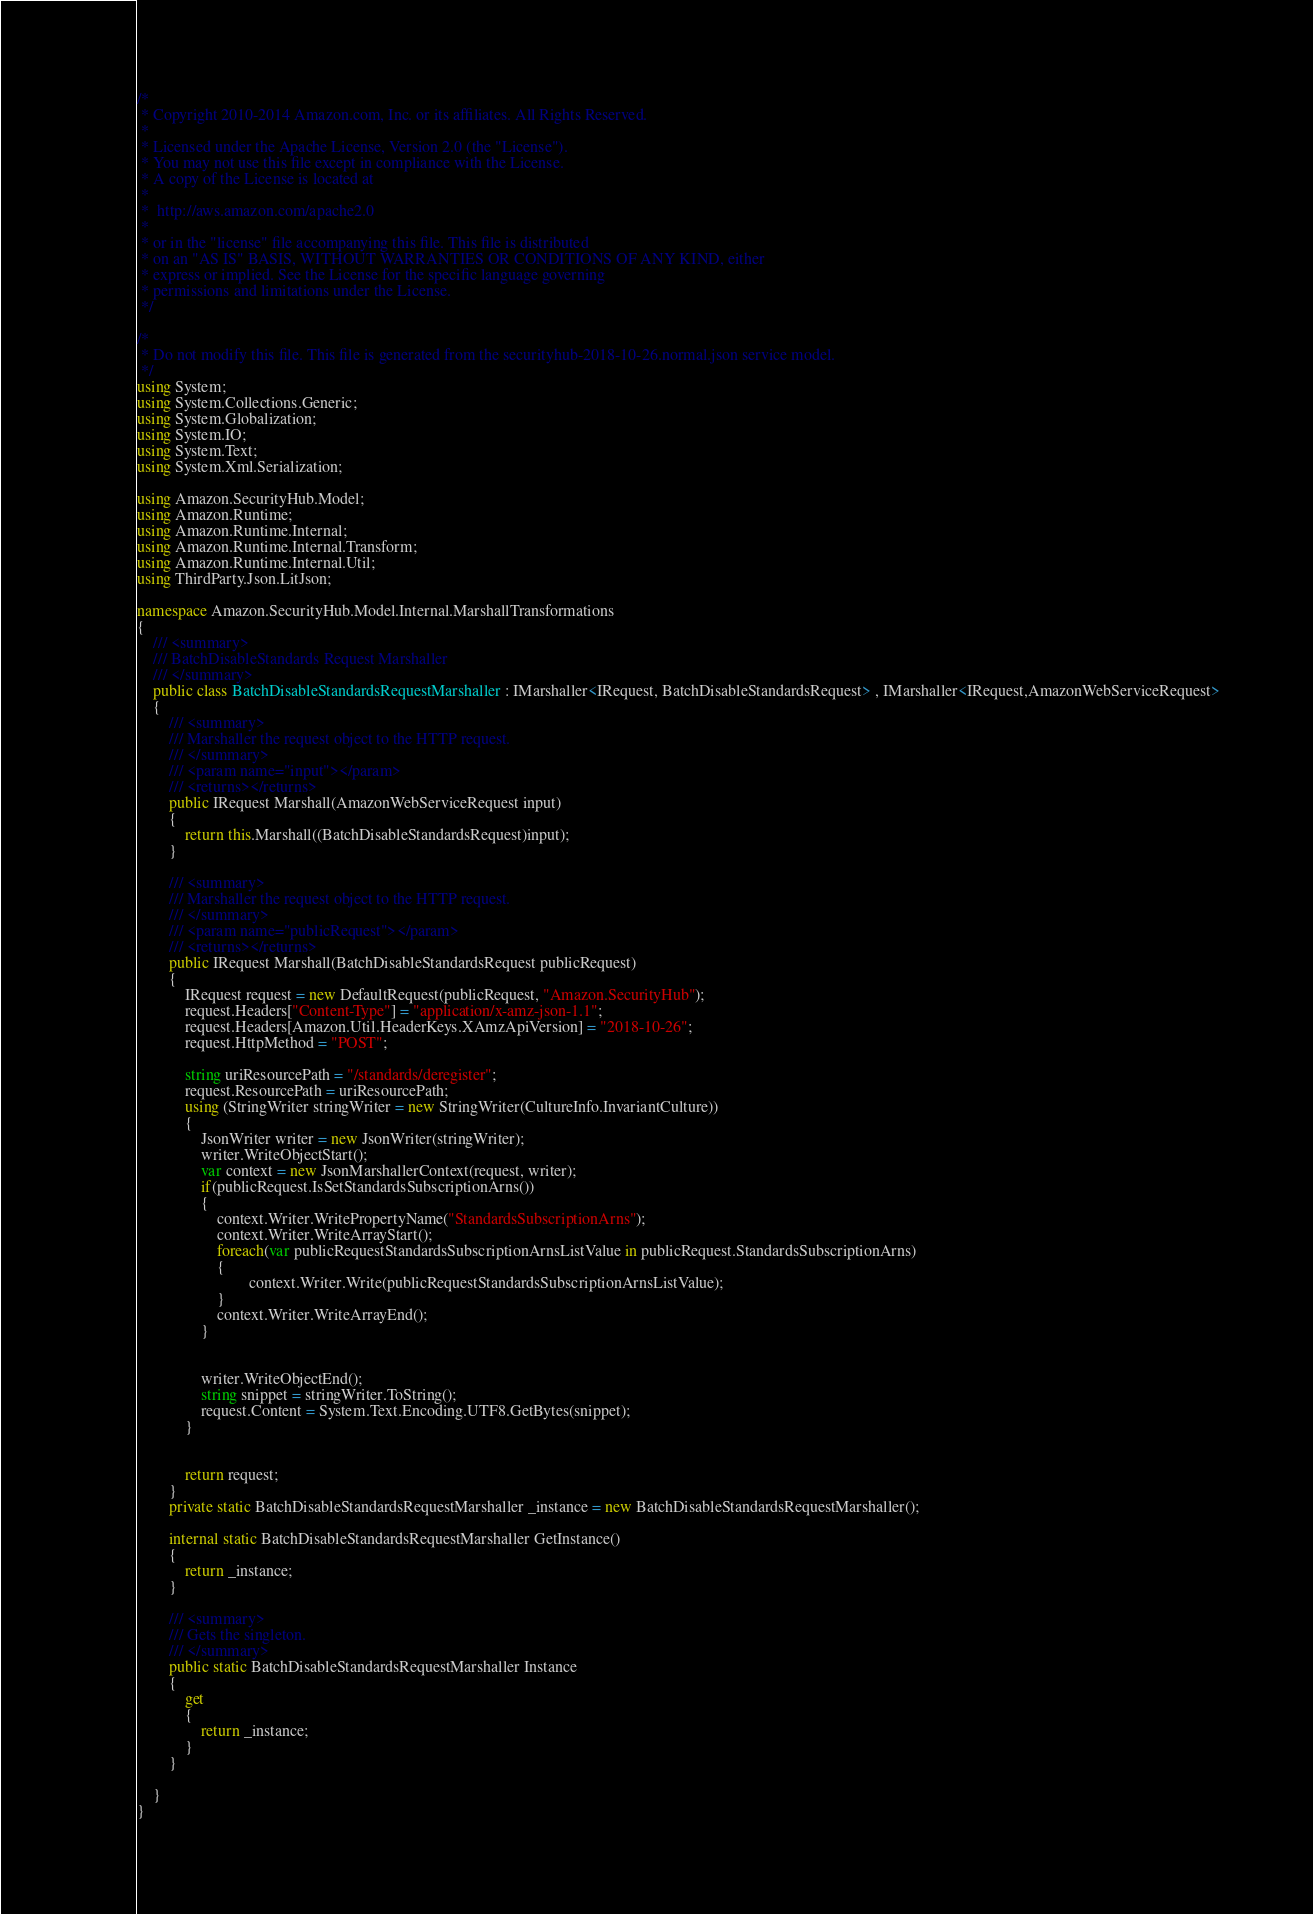Convert code to text. <code><loc_0><loc_0><loc_500><loc_500><_C#_>/*
 * Copyright 2010-2014 Amazon.com, Inc. or its affiliates. All Rights Reserved.
 * 
 * Licensed under the Apache License, Version 2.0 (the "License").
 * You may not use this file except in compliance with the License.
 * A copy of the License is located at
 * 
 *  http://aws.amazon.com/apache2.0
 * 
 * or in the "license" file accompanying this file. This file is distributed
 * on an "AS IS" BASIS, WITHOUT WARRANTIES OR CONDITIONS OF ANY KIND, either
 * express or implied. See the License for the specific language governing
 * permissions and limitations under the License.
 */

/*
 * Do not modify this file. This file is generated from the securityhub-2018-10-26.normal.json service model.
 */
using System;
using System.Collections.Generic;
using System.Globalization;
using System.IO;
using System.Text;
using System.Xml.Serialization;

using Amazon.SecurityHub.Model;
using Amazon.Runtime;
using Amazon.Runtime.Internal;
using Amazon.Runtime.Internal.Transform;
using Amazon.Runtime.Internal.Util;
using ThirdParty.Json.LitJson;

namespace Amazon.SecurityHub.Model.Internal.MarshallTransformations
{
    /// <summary>
    /// BatchDisableStandards Request Marshaller
    /// </summary>       
    public class BatchDisableStandardsRequestMarshaller : IMarshaller<IRequest, BatchDisableStandardsRequest> , IMarshaller<IRequest,AmazonWebServiceRequest>
    {
        /// <summary>
        /// Marshaller the request object to the HTTP request.
        /// </summary>  
        /// <param name="input"></param>
        /// <returns></returns>
        public IRequest Marshall(AmazonWebServiceRequest input)
        {
            return this.Marshall((BatchDisableStandardsRequest)input);
        }

        /// <summary>
        /// Marshaller the request object to the HTTP request.
        /// </summary>  
        /// <param name="publicRequest"></param>
        /// <returns></returns>
        public IRequest Marshall(BatchDisableStandardsRequest publicRequest)
        {
            IRequest request = new DefaultRequest(publicRequest, "Amazon.SecurityHub");
            request.Headers["Content-Type"] = "application/x-amz-json-1.1";
            request.Headers[Amazon.Util.HeaderKeys.XAmzApiVersion] = "2018-10-26";            
            request.HttpMethod = "POST";

            string uriResourcePath = "/standards/deregister";
            request.ResourcePath = uriResourcePath;
            using (StringWriter stringWriter = new StringWriter(CultureInfo.InvariantCulture))
            {
                JsonWriter writer = new JsonWriter(stringWriter);
                writer.WriteObjectStart();
                var context = new JsonMarshallerContext(request, writer);
                if(publicRequest.IsSetStandardsSubscriptionArns())
                {
                    context.Writer.WritePropertyName("StandardsSubscriptionArns");
                    context.Writer.WriteArrayStart();
                    foreach(var publicRequestStandardsSubscriptionArnsListValue in publicRequest.StandardsSubscriptionArns)
                    {
                            context.Writer.Write(publicRequestStandardsSubscriptionArnsListValue);
                    }
                    context.Writer.WriteArrayEnd();
                }

        
                writer.WriteObjectEnd();
                string snippet = stringWriter.ToString();
                request.Content = System.Text.Encoding.UTF8.GetBytes(snippet);
            }


            return request;
        }
        private static BatchDisableStandardsRequestMarshaller _instance = new BatchDisableStandardsRequestMarshaller();        

        internal static BatchDisableStandardsRequestMarshaller GetInstance()
        {
            return _instance;
        }

        /// <summary>
        /// Gets the singleton.
        /// </summary>  
        public static BatchDisableStandardsRequestMarshaller Instance
        {
            get
            {
                return _instance;
            }
        }

    }
}</code> 